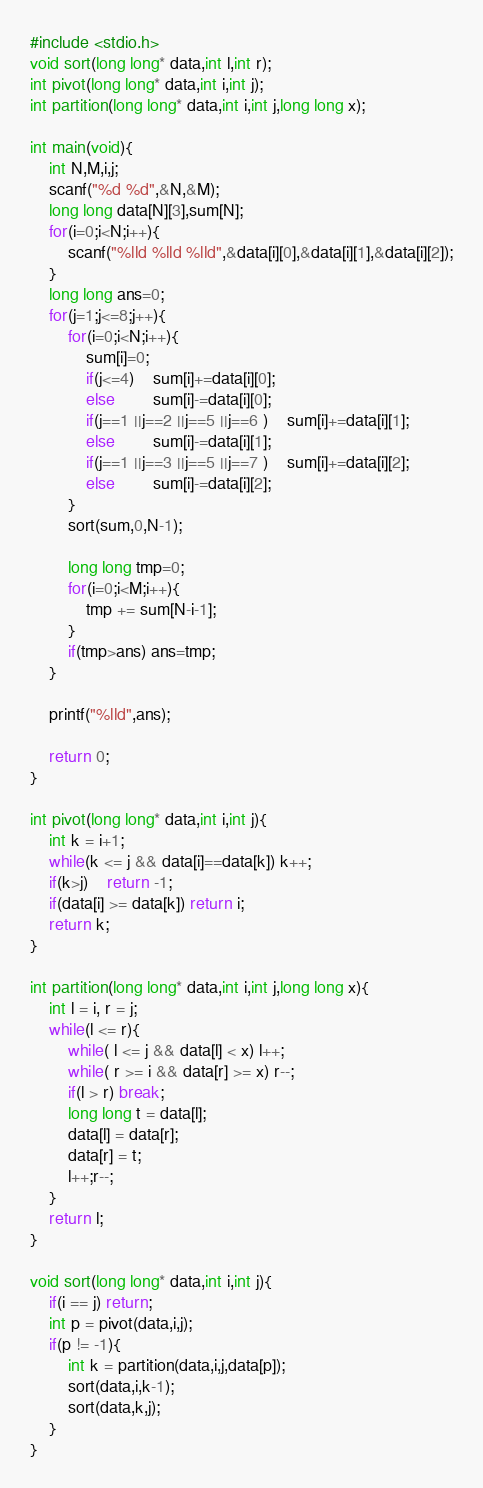<code> <loc_0><loc_0><loc_500><loc_500><_C_>#include <stdio.h>
void sort(long long* data,int l,int r);
int pivot(long long* data,int i,int j);
int partition(long long* data,int i,int j,long long x);

int main(void){
	int N,M,i,j;
	scanf("%d %d",&N,&M);
	long long data[N][3],sum[N];
	for(i=0;i<N;i++){
		scanf("%lld %lld %lld",&data[i][0],&data[i][1],&data[i][2]);
	}
	long long ans=0;
	for(j=1;j<=8;j++){
		for(i=0;i<N;i++){
			sum[i]=0;
			if(j<=4)	sum[i]+=data[i][0];
			else		sum[i]-=data[i][0];
			if(j==1 ||j==2 ||j==5 ||j==6 )	sum[i]+=data[i][1];
			else		sum[i]-=data[i][1];
			if(j==1 ||j==3 ||j==5 ||j==7 )	sum[i]+=data[i][2];
			else		sum[i]-=data[i][2];
		}
		sort(sum,0,N-1);
		
		long long tmp=0;
		for(i=0;i<M;i++){
			tmp += sum[N-i-1];
		}
		if(tmp>ans) ans=tmp;
	}
	
	printf("%lld",ans);

	return 0;
}

int pivot(long long* data,int i,int j){
	int k = i+1;
	while(k <= j && data[i]==data[k]) k++;
	if(k>j)	return -1;
	if(data[i] >= data[k]) return i;
	return k;
}

int partition(long long* data,int i,int j,long long x){
	int l = i, r = j;
	while(l <= r){
		while( l <= j && data[l] < x) l++;
		while( r >= i && data[r] >= x) r--;
		if(l > r) break;
		long long t = data[l];
		data[l] = data[r];
		data[r] = t;
		l++;r--;
	}
	return l;
}

void sort(long long* data,int i,int j){
	if(i == j) return;
	int p = pivot(data,i,j);
	if(p != -1){
		int k = partition(data,i,j,data[p]);
		sort(data,i,k-1);
		sort(data,k,j);
	}
}</code> 